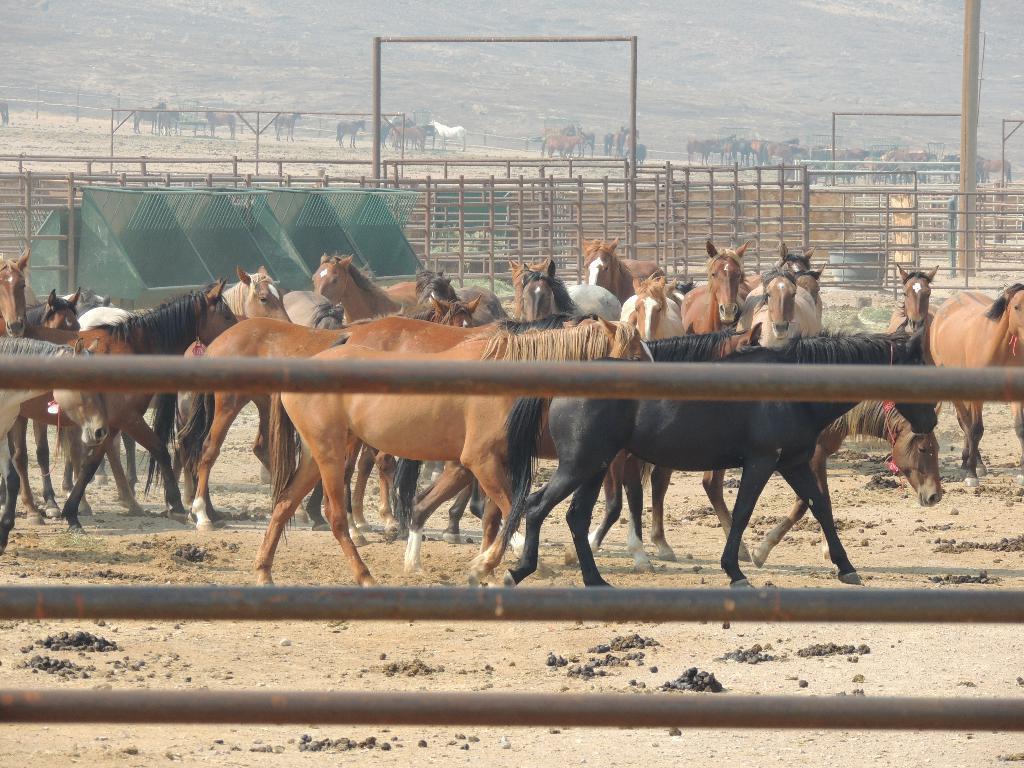Describe this image in one or two sentences. In the image we can see there are many horses of different colors. Here we can see the fence, poles and the background is slightly foggy. 